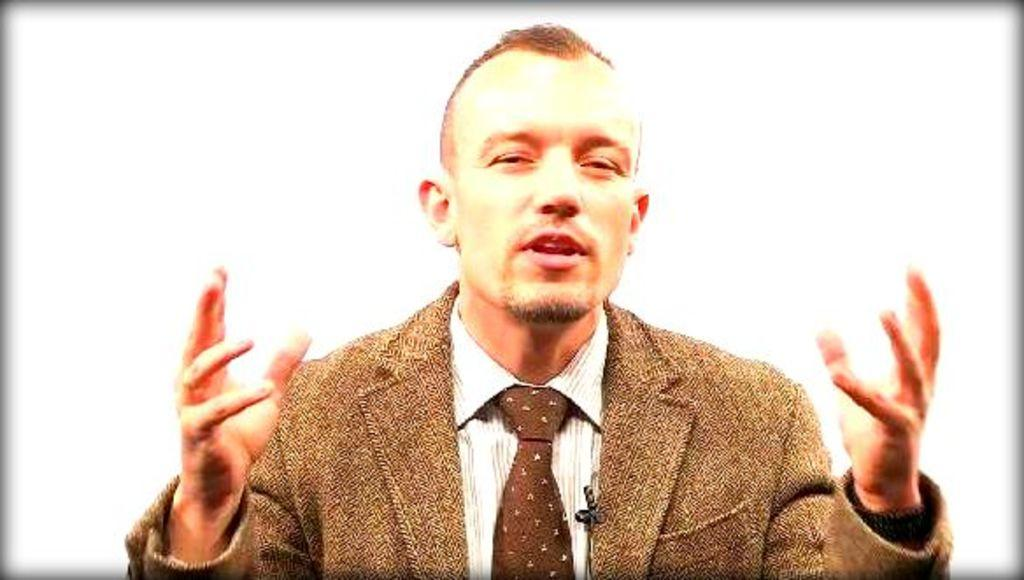Who is the main subject in the image? There is a man in the picture. What is the man doing in the image? The man is lifting his hands up. What color is the background of the image? The background of the image is white. What is the man wearing in the image? The man is wearing a brown coat and a tie. How many fish can be seen swimming in the man's head in the image? There are no fish visible in the image, nor are there any fish swimming in the man's head. 